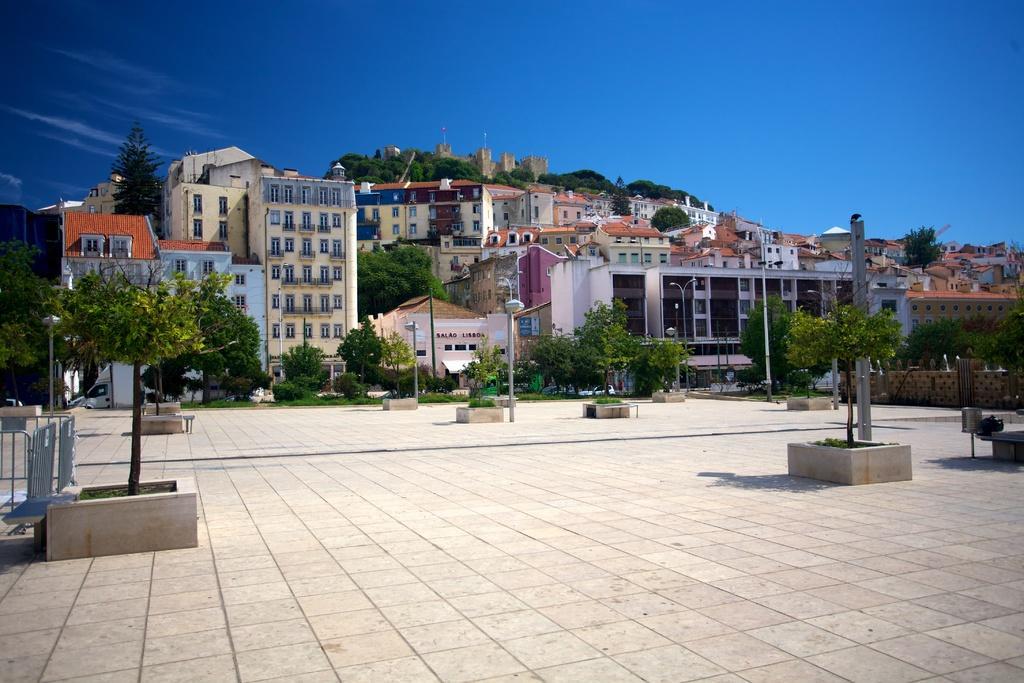In one or two sentences, can you explain what this image depicts? In the middle of the image there are some trees and plants and poles. Behind them there are some buildings. At the top of the image there are some clouds and sky. 